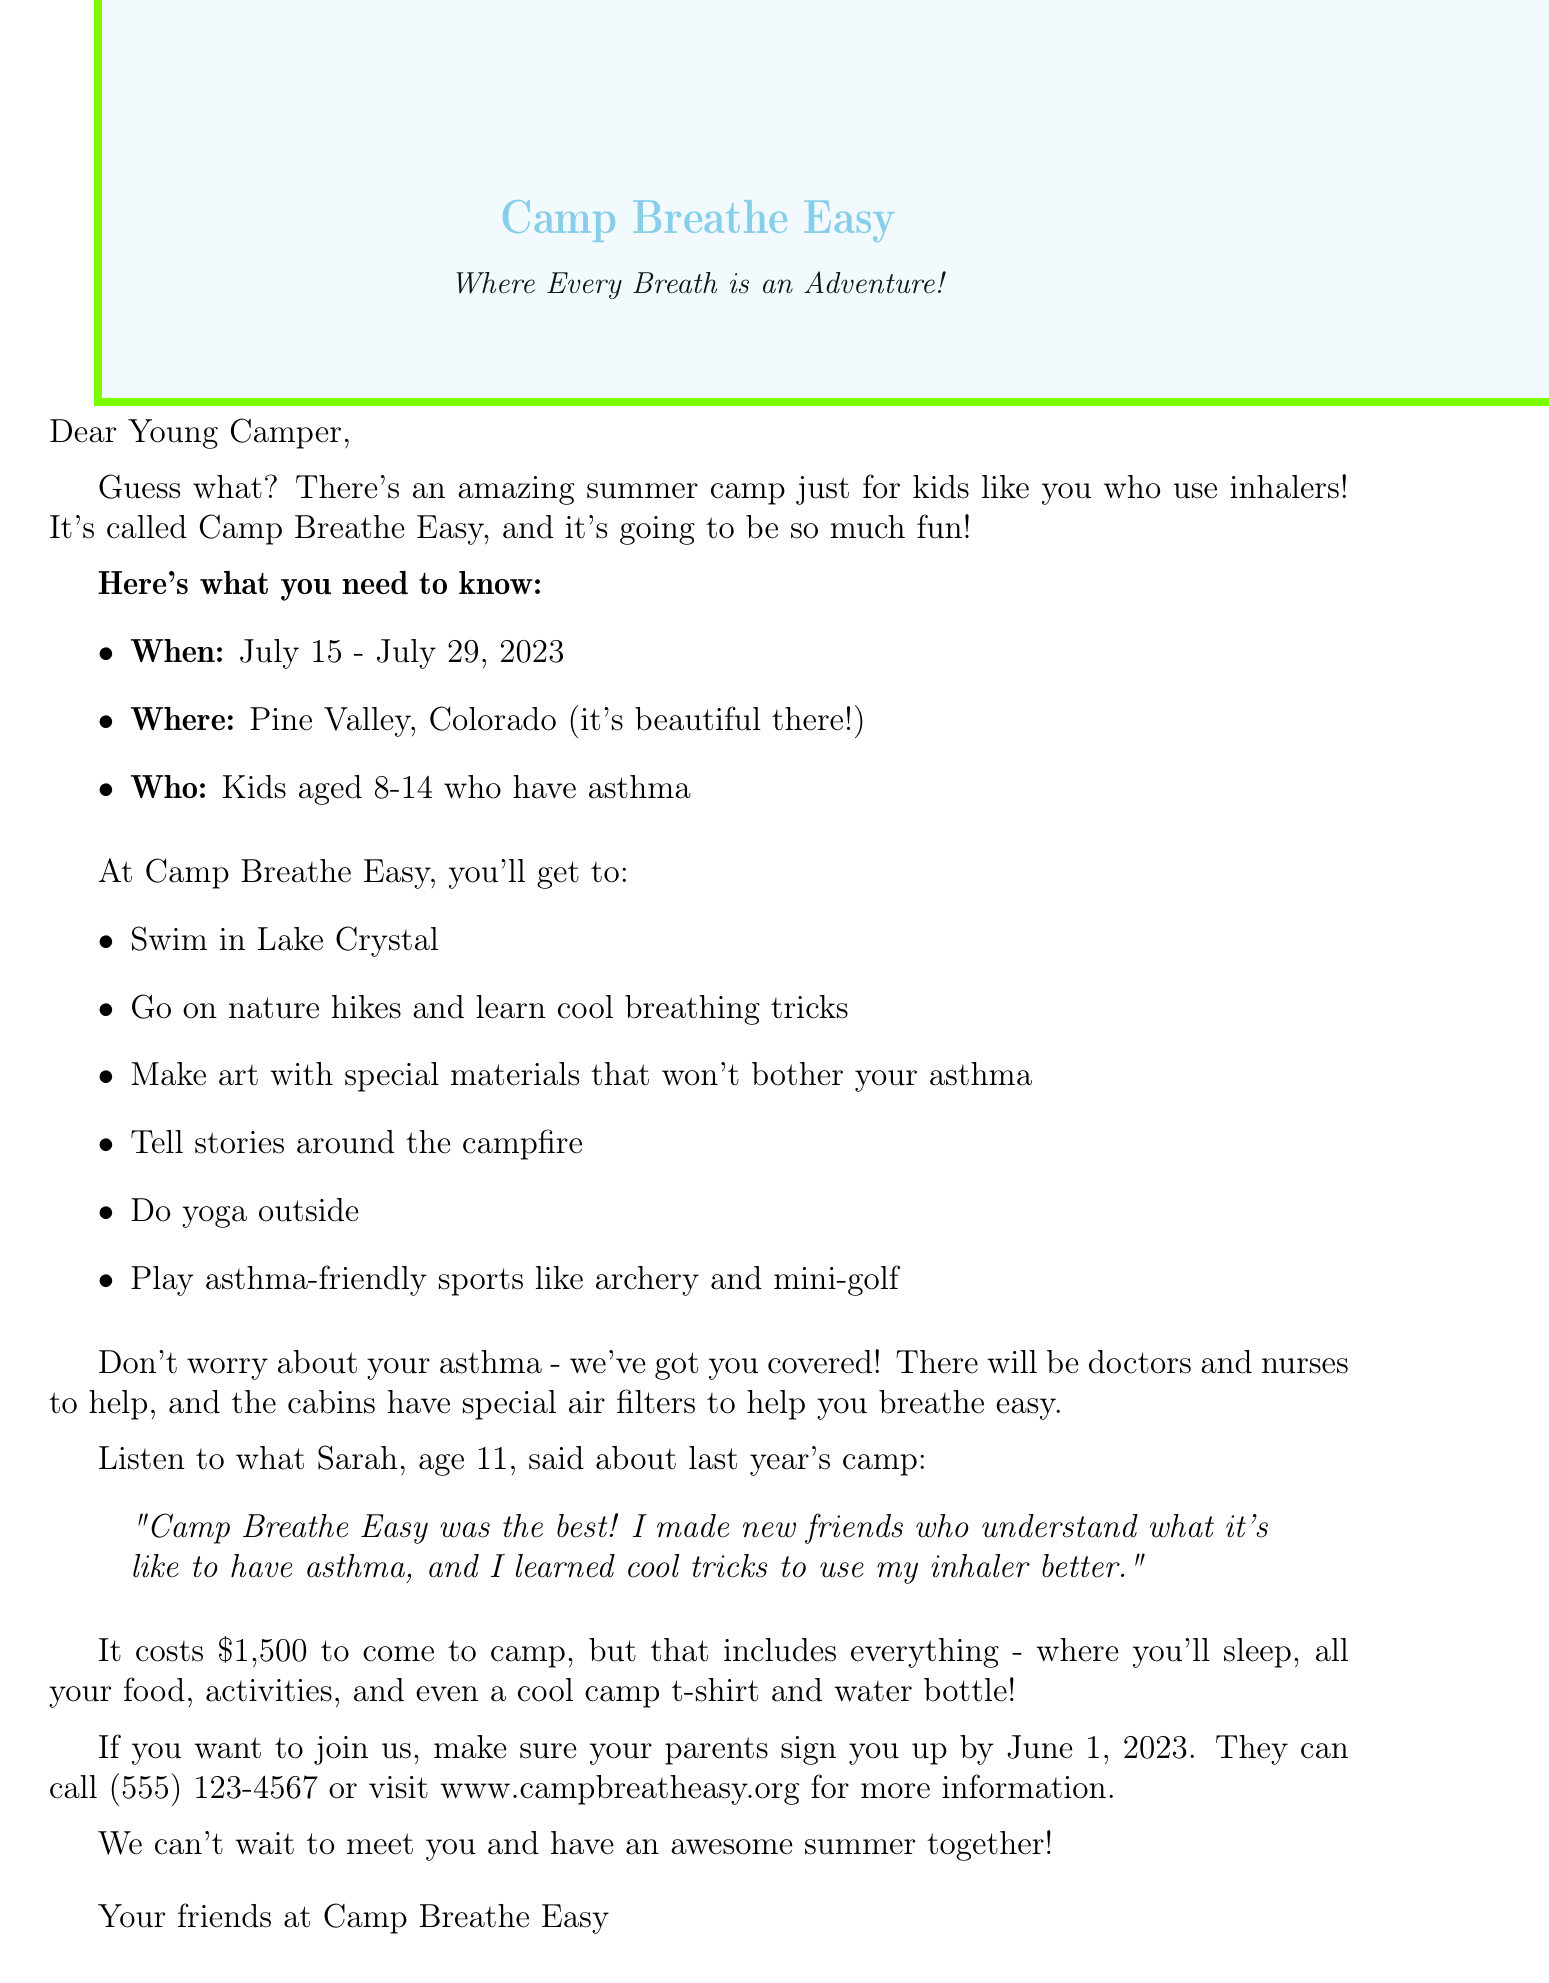What is the name of the camp? The name of the camp is stated in the document as Camp Breathe Easy.
Answer: Camp Breathe Easy What are the camp dates? The document provides specific dates for the camp as July 15 - July 29, 2023.
Answer: July 15 - July 29, 2023 How much does the camp cost? The document clearly states the total cost of attending the camp, which is $1,500.
Answer: $1,500 What age group is the camp for? The document mentions that the camp is for kids aged 8-14 years old.
Answer: 8-14 years old Who is one of the medical staff? The document lists the medical staff, naming Dr. Emily Rodriguez as a Pediatric Pulmonologist.
Answer: Dr. Emily Rodriguez What special feature helps with breathing? The document outlines special air filters in the cabins to help with breathing.
Answer: HEPA filters What type of activities are planned? A variety of activities are listed, including swimming and nature hikes.
Answer: Swimming in Lake Crystal What is a feedback quote from a camper? The document includes a testimonial quote from Sarah Johnson, highlighting her positive experience.
Answer: "Camp Breathe Easy was the best!" When is the registration deadline? The document specifies the registration deadline as June 1, 2023.
Answer: June 1, 2023 